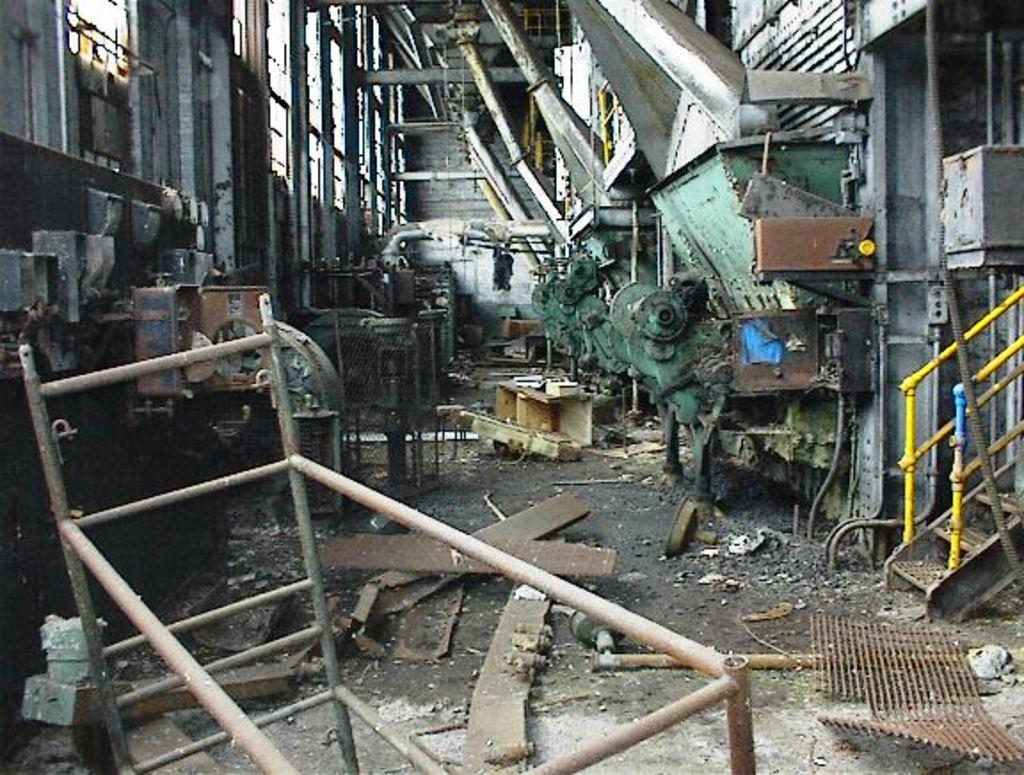What type of objects can be seen in the image? There are machines and iron objects in the image. Can you describe the machines in the image? Unfortunately, the provided facts do not give enough information to describe the machines in detail. What is the purpose of the iron objects in the image? The purpose of the iron objects in the image cannot be determined from the provided facts. What type of prose is being recited by the man in the image? There is no man or prose present in the image; it only features machines and iron objects. 